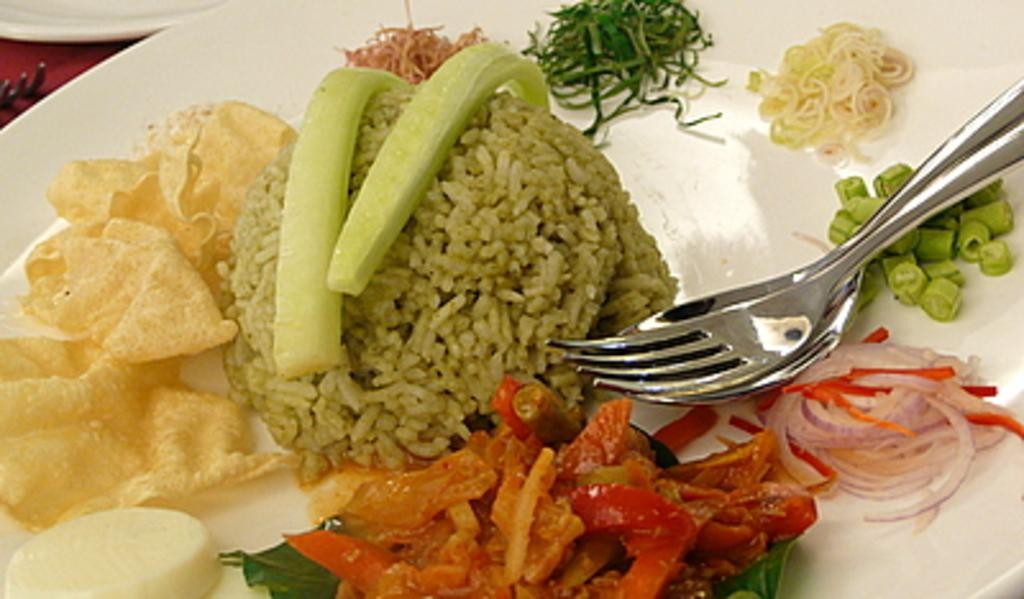What is on the white platter in the foreground of the image? There are food items on a white platter in the foreground of the image. What utensils are present on the white platter? A spoon and a fork are present on the white platter. What is at the top of the image? There is a platter at the top of the image. What utensil is present on the platter at the top of the image? A fork is present on the platter at the top of the image. What direction is the food moving in the image? The food is not moving in the image; it is stationary on the platter. What type of food can be seen slipping off the platter in the image? There is no food slipping off the platter in the image. 